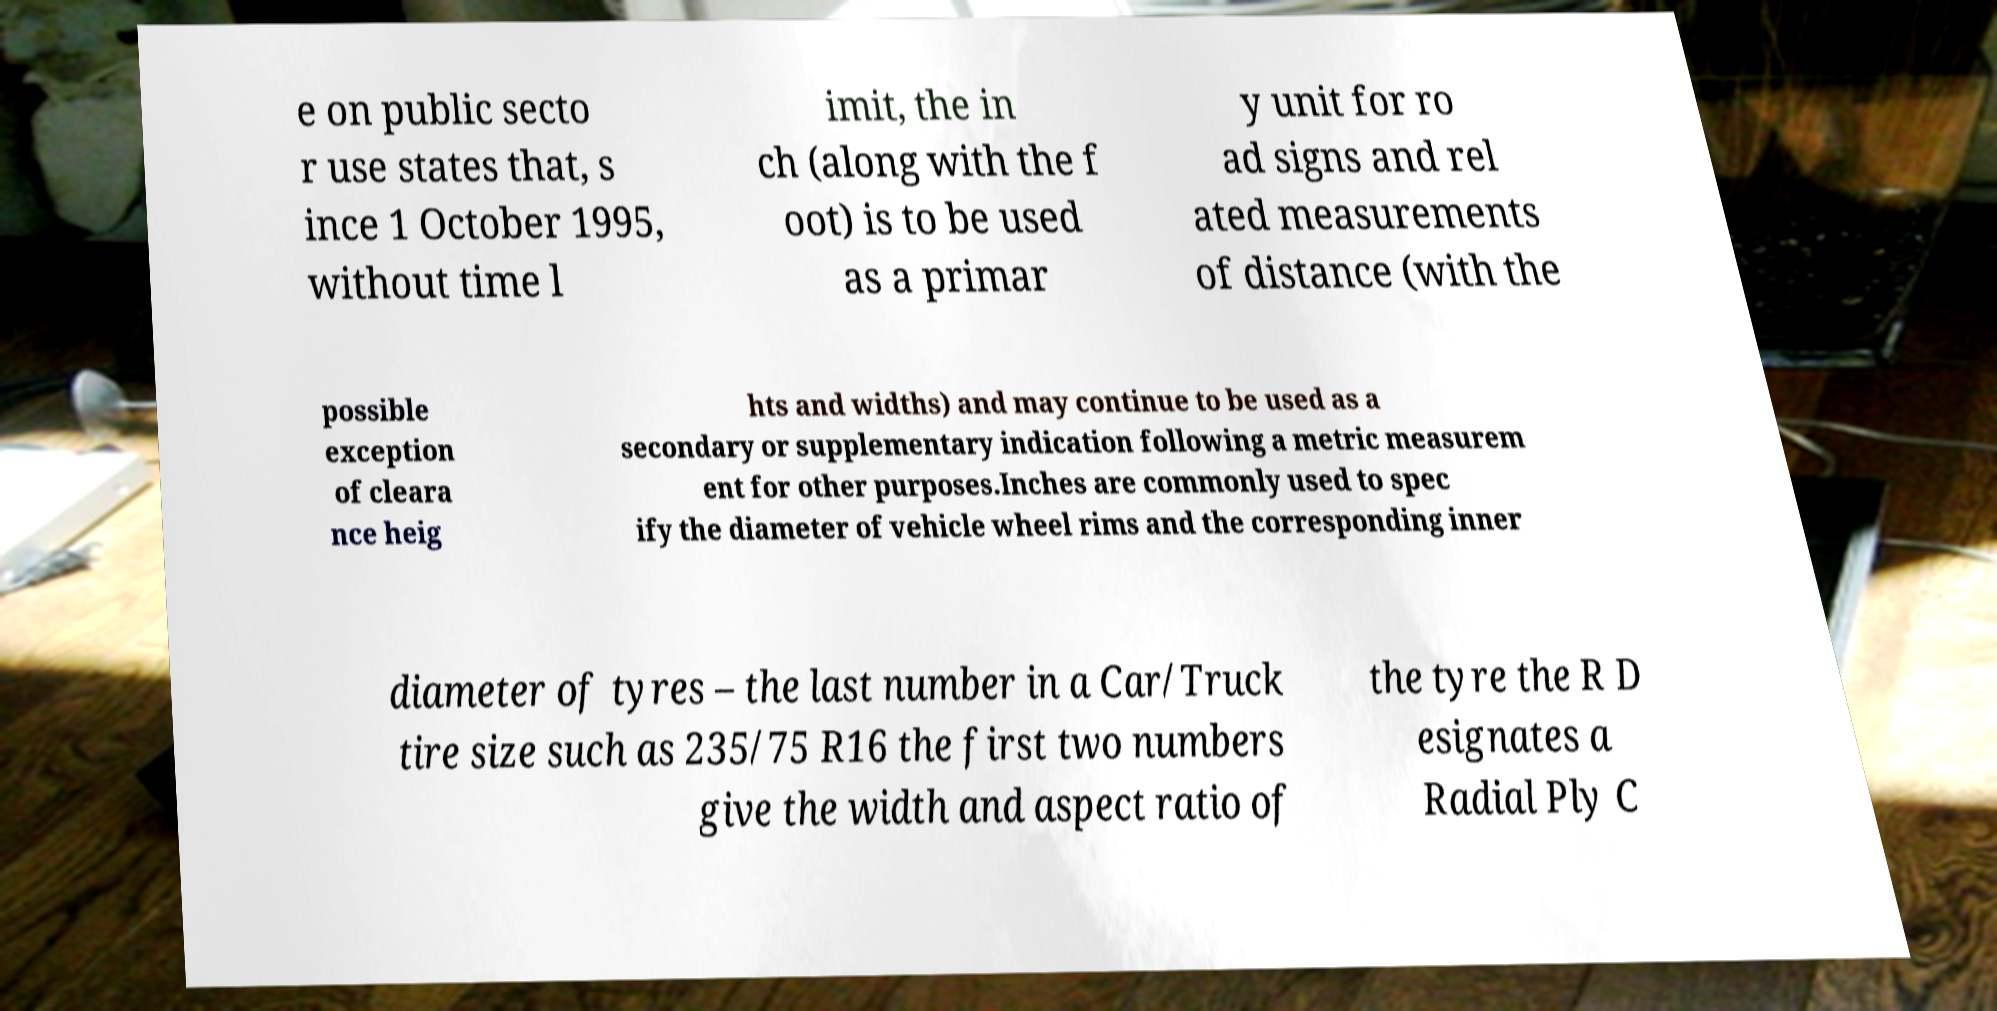There's text embedded in this image that I need extracted. Can you transcribe it verbatim? e on public secto r use states that, s ince 1 October 1995, without time l imit, the in ch (along with the f oot) is to be used as a primar y unit for ro ad signs and rel ated measurements of distance (with the possible exception of cleara nce heig hts and widths) and may continue to be used as a secondary or supplementary indication following a metric measurem ent for other purposes.Inches are commonly used to spec ify the diameter of vehicle wheel rims and the corresponding inner diameter of tyres – the last number in a Car/Truck tire size such as 235/75 R16 the first two numbers give the width and aspect ratio of the tyre the R D esignates a Radial Ply C 